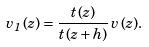Convert formula to latex. <formula><loc_0><loc_0><loc_500><loc_500>v _ { 1 } \, ( z ) = \frac { t \, ( z ) } { t \, ( z + h ) } \, v \, ( z ) .</formula> 